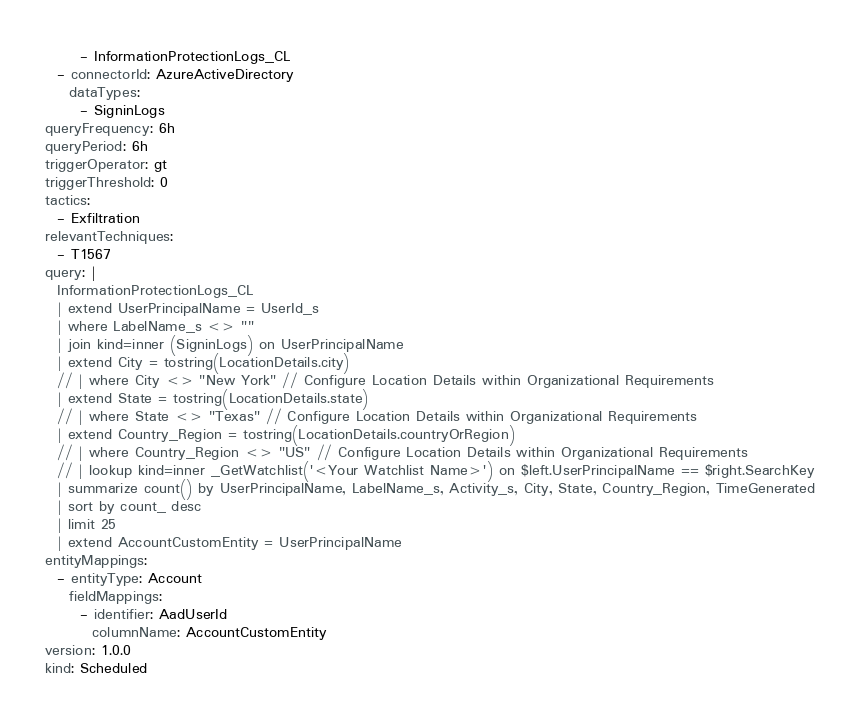<code> <loc_0><loc_0><loc_500><loc_500><_YAML_>      - InformationProtectionLogs_CL 
  - connectorId: AzureActiveDirectory
    dataTypes:
      - SigninLogs 
queryFrequency: 6h
queryPeriod: 6h
triggerOperator: gt
triggerThreshold: 0
tactics:
  - Exfiltration
relevantTechniques:
  - T1567
query: |
  InformationProtectionLogs_CL
  | extend UserPrincipalName = UserId_s
  | where LabelName_s <> ""
  | join kind=inner (SigninLogs) on UserPrincipalName
  | extend City = tostring(LocationDetails.city)
  // | where City <> "New York" // Configure Location Details within Organizational Requirements
  | extend State = tostring(LocationDetails.state)
  // | where State <> "Texas" // Configure Location Details within Organizational Requirements
  | extend Country_Region = tostring(LocationDetails.countryOrRegion)
  // | where Country_Region <> "US" // Configure Location Details within Organizational Requirements
  // | lookup kind=inner _GetWatchlist('<Your Watchlist Name>') on $left.UserPrincipalName == $right.SearchKey
  | summarize count() by UserPrincipalName, LabelName_s, Activity_s, City, State, Country_Region, TimeGenerated
  | sort by count_ desc
  | limit 25
  | extend AccountCustomEntity = UserPrincipalName
entityMappings:
  - entityType: Account
    fieldMappings:
      - identifier: AadUserId
        columnName: AccountCustomEntity
version: 1.0.0
kind: Scheduled</code> 